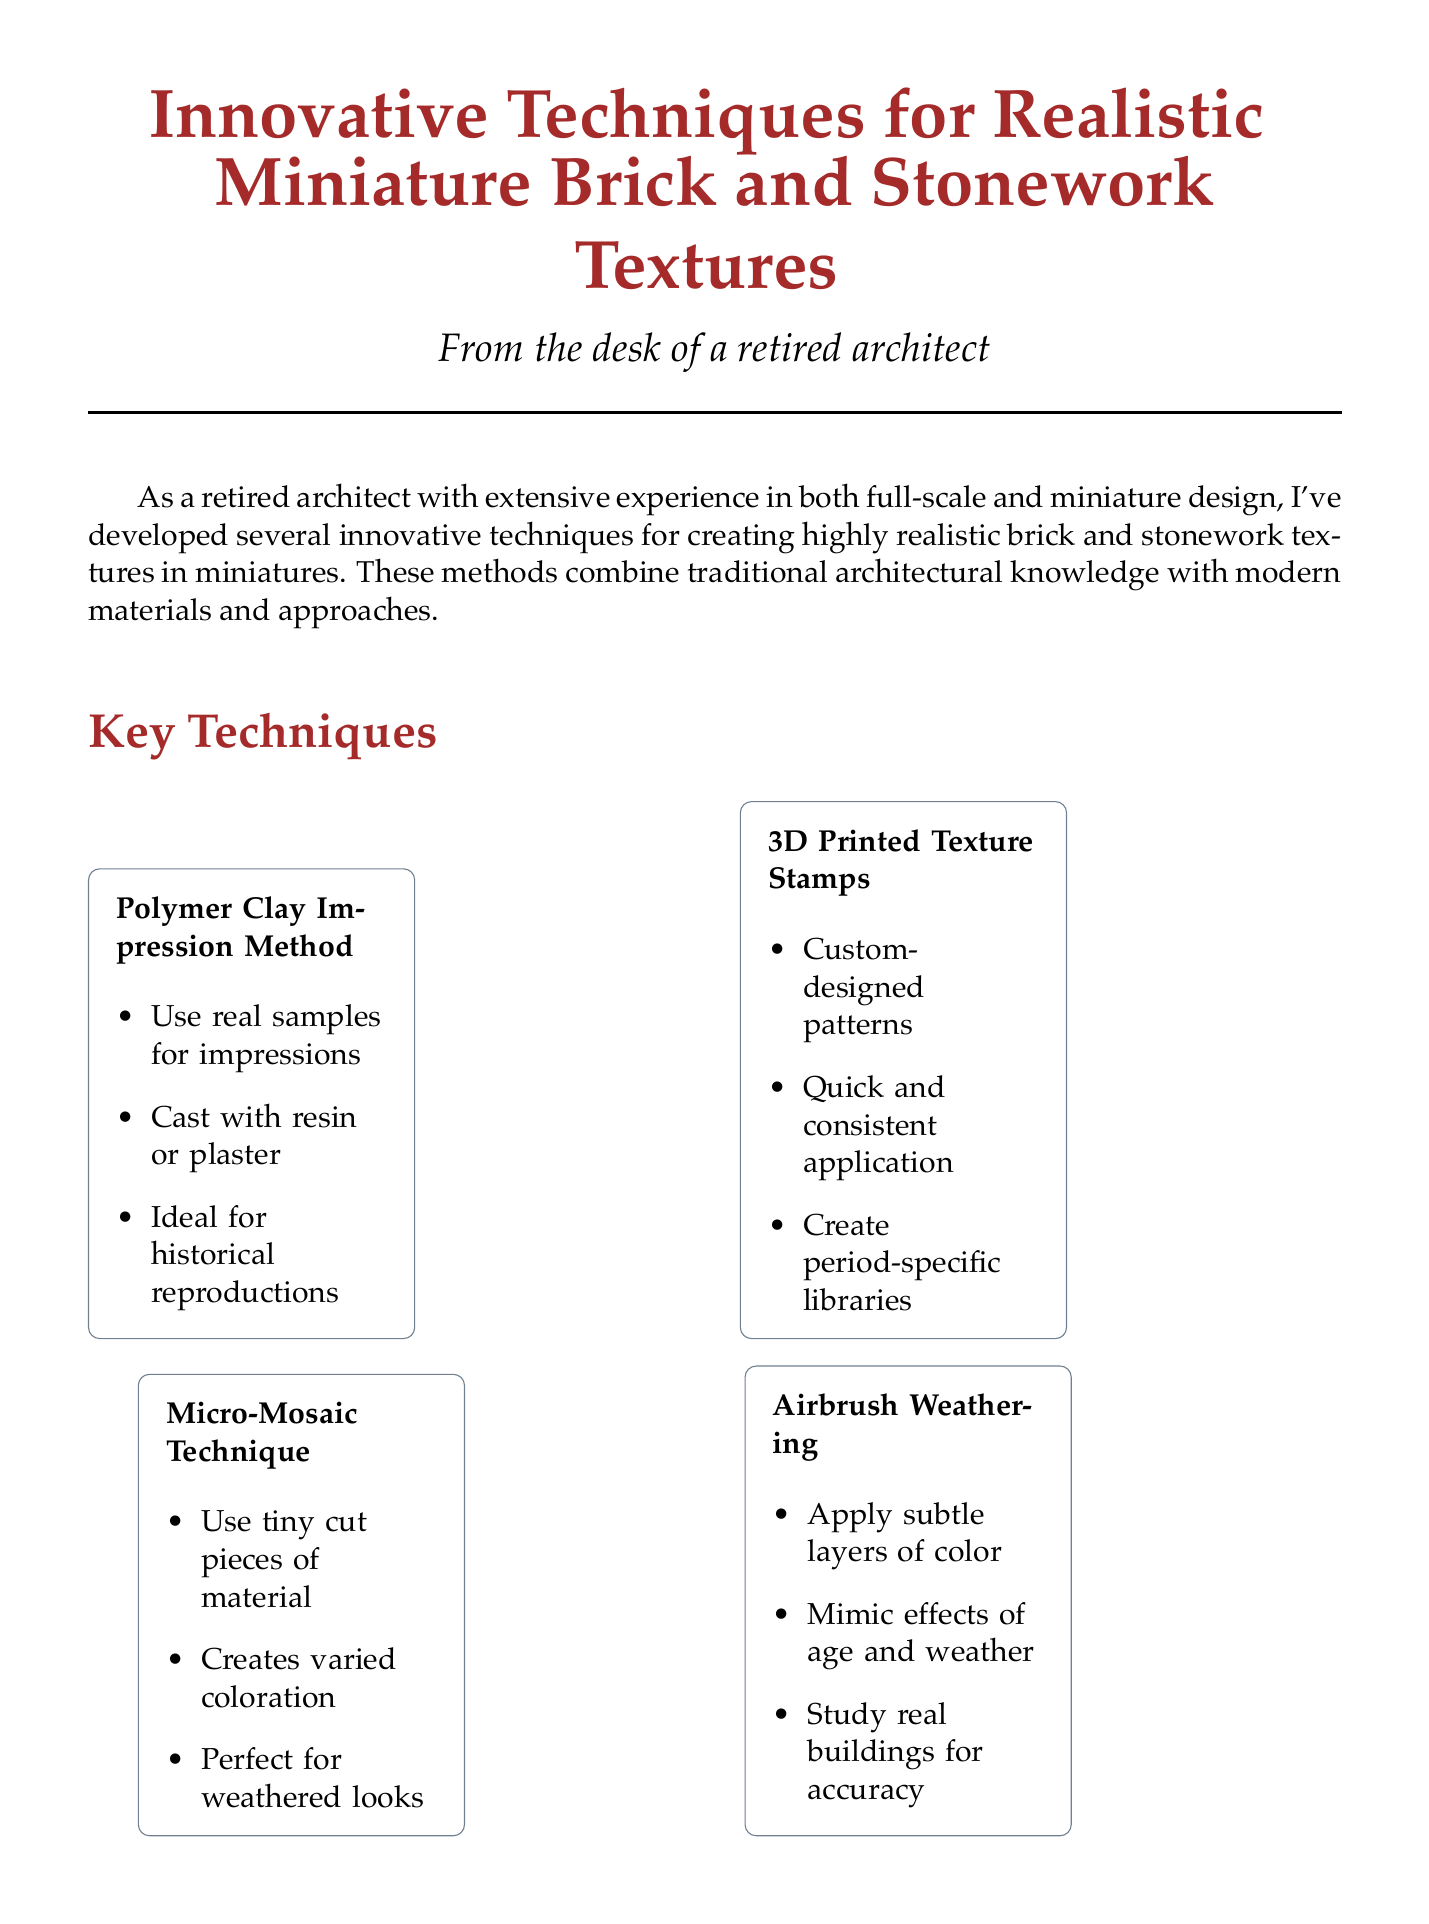what is the title of the document? The title is specified at the top of the document.
Answer: Innovative Techniques for Realistic Miniature Brick and Stonework Textures how many techniques are detailed in the document? The document lists the techniques under the 'Key Techniques' section.
Answer: four which technique uses tiny cut pieces of material? The detailed description of this technique indicates its application with small materials.
Answer: Micro-Mosaic Technique what is one material used in the Polymer Clay Impression Method? Each technique includes a list of materials used.
Answer: Sculpey polymer clay what is the outcome of the Victorian London Street Scene project? The outcome provides feedback on the success of the project described in the case studies.
Answer: High level of historical accuracy, earning praise from architectural historians what is the main purpose of combining these innovative techniques? The conclusion summarizes the goal of using different techniques in miniature design.
Answer: Create miniature brick and stonework textures that are virtually indistinguishable from their full-scale counterparts which tool is required for Airbrush Weathering? Each technique specifies required materials or tools needed for execution.
Answer: Airbrush what type of projects can benefit from creating a library of stamps? The reasoning behind creating a library is explained in relation to one of the techniques.
Answer: Various brick and stone patterns 